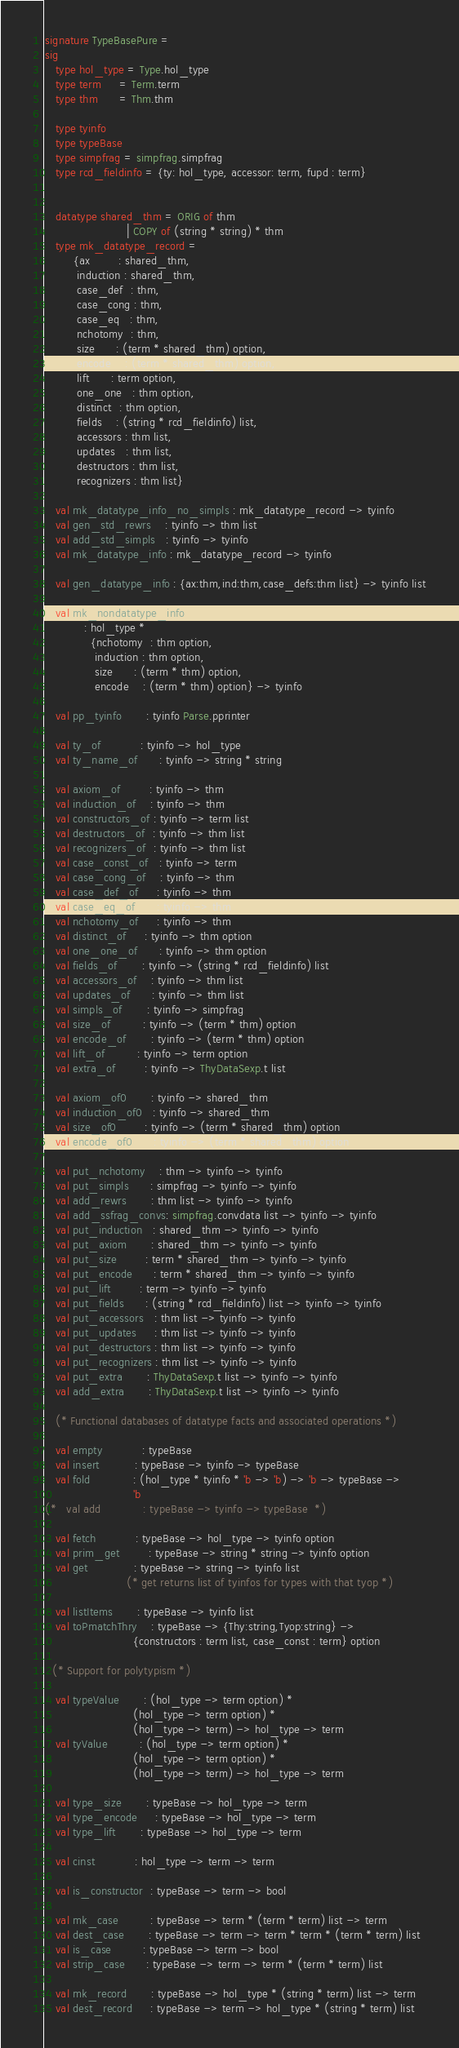Convert code to text. <code><loc_0><loc_0><loc_500><loc_500><_SML_>signature TypeBasePure =
sig
   type hol_type = Type.hol_type
   type term     = Term.term
   type thm      = Thm.thm

   type tyinfo
   type typeBase
   type simpfrag = simpfrag.simpfrag
   type rcd_fieldinfo = {ty: hol_type, accessor: term, fupd : term}


   datatype shared_thm = ORIG of thm
                       | COPY of (string * string) * thm
   type mk_datatype_record =
        {ax        : shared_thm,
         induction : shared_thm,
         case_def  : thm,
         case_cong : thm,
         case_eq   : thm,
         nchotomy  : thm,
         size      : (term * shared_thm) option,
         encode    : (term * shared_thm) option,
         lift      : term option,
         one_one   : thm option,
         distinct  : thm option,
         fields    : (string * rcd_fieldinfo) list,
         accessors : thm list,
         updates   : thm list,
         destructors : thm list,
         recognizers : thm list}

   val mk_datatype_info_no_simpls : mk_datatype_record -> tyinfo
   val gen_std_rewrs    : tyinfo -> thm list
   val add_std_simpls   : tyinfo -> tyinfo
   val mk_datatype_info : mk_datatype_record -> tyinfo

   val gen_datatype_info : {ax:thm,ind:thm,case_defs:thm list} -> tyinfo list

   val mk_nondatatype_info
           : hol_type *
             {nchotomy  : thm option,
              induction : thm option,
              size      : (term * thm) option,
              encode    : (term * thm) option} -> tyinfo

   val pp_tyinfo       : tyinfo Parse.pprinter

   val ty_of           : tyinfo -> hol_type
   val ty_name_of      : tyinfo -> string * string

   val axiom_of        : tyinfo -> thm
   val induction_of    : tyinfo -> thm
   val constructors_of : tyinfo -> term list
   val destructors_of  : tyinfo -> thm list
   val recognizers_of  : tyinfo -> thm list
   val case_const_of   : tyinfo -> term
   val case_cong_of    : tyinfo -> thm
   val case_def_of     : tyinfo -> thm
   val case_eq_of      : tyinfo -> thm
   val nchotomy_of     : tyinfo -> thm
   val distinct_of     : tyinfo -> thm option
   val one_one_of      : tyinfo -> thm option
   val fields_of       : tyinfo -> (string * rcd_fieldinfo) list
   val accessors_of    : tyinfo -> thm list
   val updates_of      : tyinfo -> thm list
   val simpls_of       : tyinfo -> simpfrag
   val size_of         : tyinfo -> (term * thm) option
   val encode_of       : tyinfo -> (term * thm) option
   val lift_of         : tyinfo -> term option
   val extra_of        : tyinfo -> ThyDataSexp.t list

   val axiom_of0       : tyinfo -> shared_thm
   val induction_of0   : tyinfo -> shared_thm
   val size_of0        : tyinfo -> (term * shared_thm) option
   val encode_of0      : tyinfo -> (term * shared_thm) option

   val put_nchotomy    : thm -> tyinfo -> tyinfo
   val put_simpls      : simpfrag -> tyinfo -> tyinfo
   val add_rewrs       : thm list -> tyinfo -> tyinfo
   val add_ssfrag_convs: simpfrag.convdata list -> tyinfo -> tyinfo
   val put_induction   : shared_thm -> tyinfo -> tyinfo
   val put_axiom       : shared_thm -> tyinfo -> tyinfo
   val put_size        : term * shared_thm -> tyinfo -> tyinfo
   val put_encode      : term * shared_thm -> tyinfo -> tyinfo
   val put_lift        : term -> tyinfo -> tyinfo
   val put_fields      : (string * rcd_fieldinfo) list -> tyinfo -> tyinfo
   val put_accessors   : thm list -> tyinfo -> tyinfo
   val put_updates     : thm list -> tyinfo -> tyinfo
   val put_destructors : thm list -> tyinfo -> tyinfo
   val put_recognizers : thm list -> tyinfo -> tyinfo
   val put_extra       : ThyDataSexp.t list -> tyinfo -> tyinfo
   val add_extra       : ThyDataSexp.t list -> tyinfo -> tyinfo

   (* Functional databases of datatype facts and associated operations *)

   val empty           : typeBase
   val insert          : typeBase -> tyinfo -> typeBase
   val fold            : (hol_type * tyinfo * 'b -> 'b) -> 'b -> typeBase ->
                         'b
(*   val add             : typeBase -> tyinfo -> typeBase  *)

   val fetch           : typeBase -> hol_type -> tyinfo option
   val prim_get        : typeBase -> string * string -> tyinfo option
   val get             : typeBase -> string -> tyinfo list
                       (* get returns list of tyinfos for types with that tyop *)

   val listItems       : typeBase -> tyinfo list
   val toPmatchThry    : typeBase -> {Thy:string,Tyop:string} ->
                         {constructors : term list, case_const : term} option

  (* Support for polytypism *)

   val typeValue       : (hol_type -> term option) *
                         (hol_type -> term option) *
                         (hol_type -> term) -> hol_type -> term
   val tyValue         : (hol_type -> term option) *
                         (hol_type -> term option) *
                         (hol_type -> term) -> hol_type -> term

   val type_size       : typeBase -> hol_type -> term
   val type_encode     : typeBase -> hol_type -> term
   val type_lift       : typeBase -> hol_type -> term

   val cinst           : hol_type -> term -> term

   val is_constructor  : typeBase -> term -> bool

   val mk_case         : typeBase -> term * (term * term) list -> term
   val dest_case       : typeBase -> term -> term * term * (term * term) list
   val is_case         : typeBase -> term -> bool
   val strip_case      : typeBase -> term -> term * (term * term) list

   val mk_record       : typeBase -> hol_type * (string * term) list -> term
   val dest_record     : typeBase -> term -> hol_type * (string * term) list</code> 